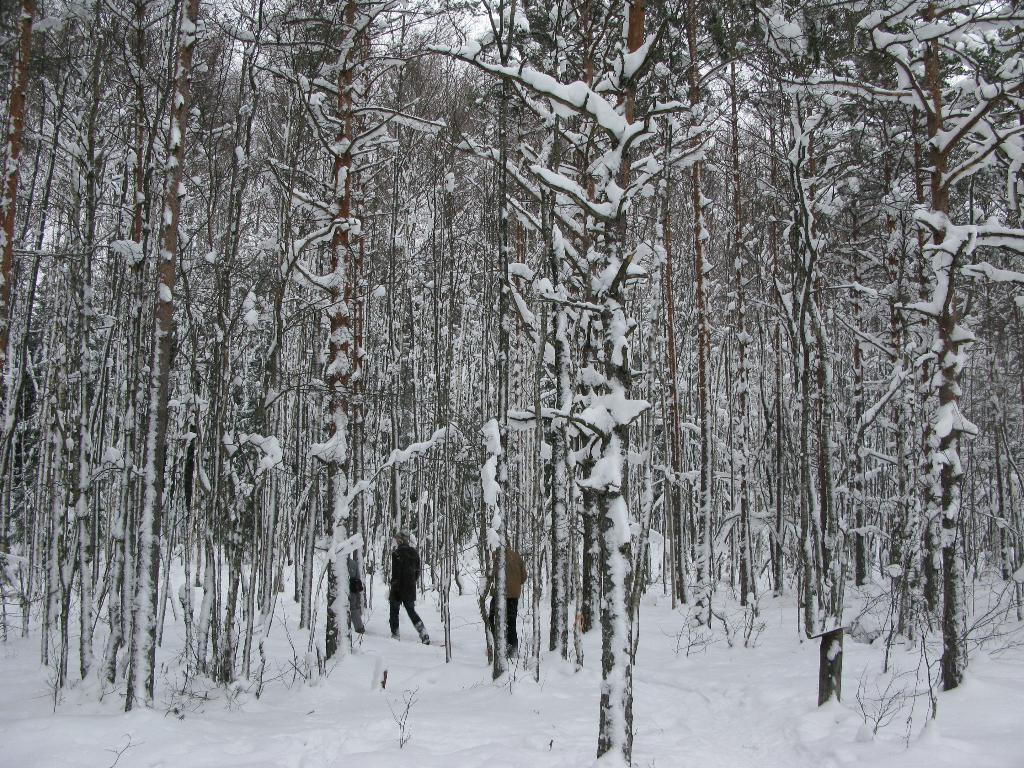How many people are in the image? There are two persons standing in the image. What is the surface they are standing on? The persons are standing on snow. What can be seen in the background of the image? There is a group of trees in the background of the image. What type of fang can be seen in the image? There is no fang present in the image. What is the best way to reach the top of the trees in the image? The image does not provide enough information to determine the best way to reach the top of the trees. 